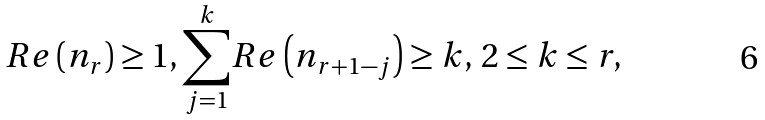Convert formula to latex. <formula><loc_0><loc_0><loc_500><loc_500>R e \left ( n _ { r } \right ) \geq 1 , \overset { k } { \underset { j = 1 } { \sum } } R e \left ( n _ { r + 1 - j } \right ) \geq k , \, 2 \leq k \leq r ,</formula> 